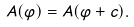<formula> <loc_0><loc_0><loc_500><loc_500>A ( \varphi ) = A ( \varphi + c ) .</formula> 